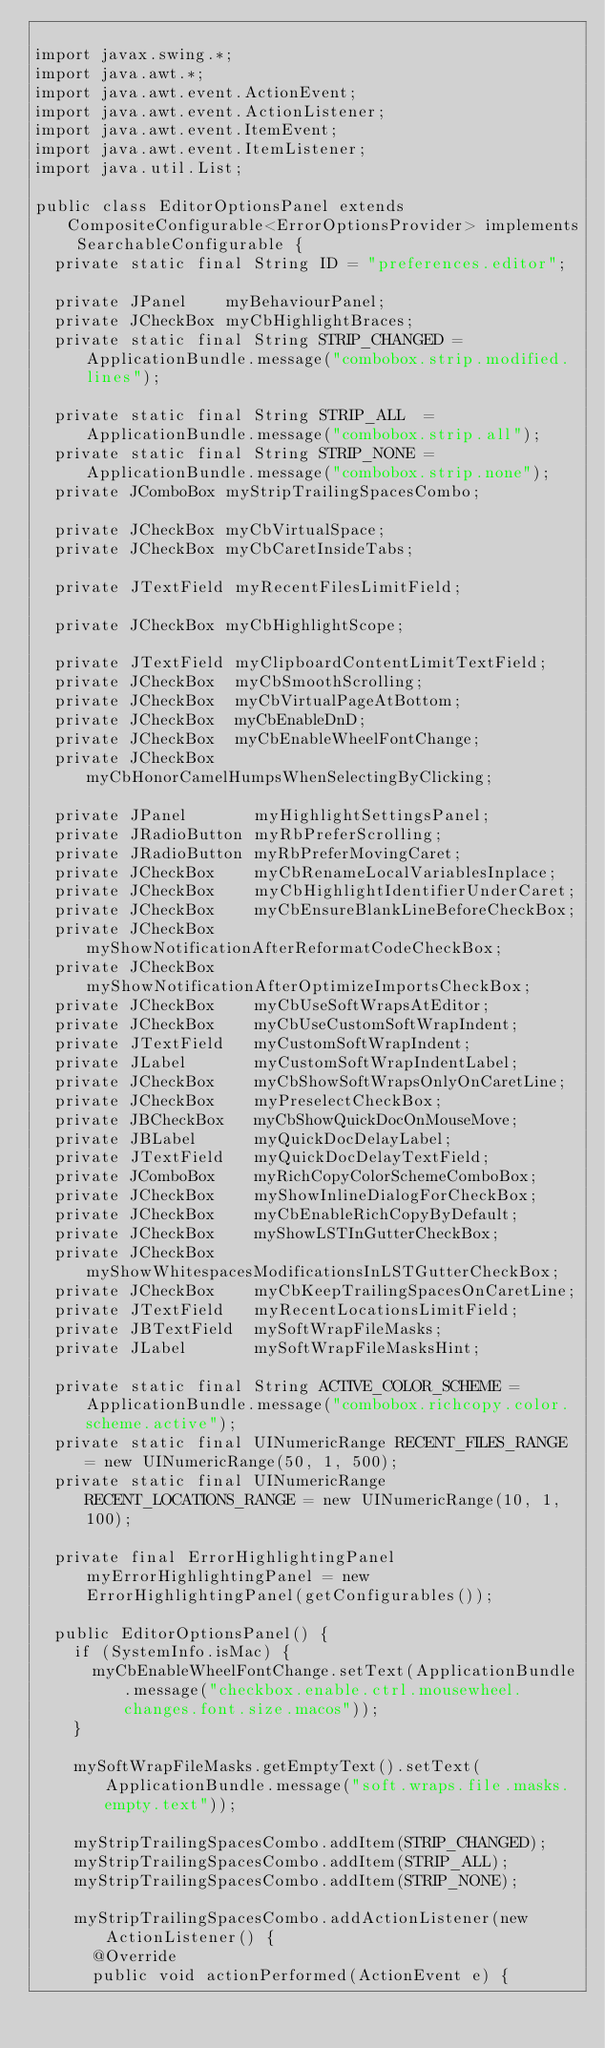Convert code to text. <code><loc_0><loc_0><loc_500><loc_500><_Java_>
import javax.swing.*;
import java.awt.*;
import java.awt.event.ActionEvent;
import java.awt.event.ActionListener;
import java.awt.event.ItemEvent;
import java.awt.event.ItemListener;
import java.util.List;

public class EditorOptionsPanel extends CompositeConfigurable<ErrorOptionsProvider> implements SearchableConfigurable {
  private static final String ID = "preferences.editor";

  private JPanel    myBehaviourPanel;
  private JCheckBox myCbHighlightBraces;
  private static final String STRIP_CHANGED = ApplicationBundle.message("combobox.strip.modified.lines");

  private static final String STRIP_ALL  = ApplicationBundle.message("combobox.strip.all");
  private static final String STRIP_NONE = ApplicationBundle.message("combobox.strip.none");
  private JComboBox myStripTrailingSpacesCombo;

  private JCheckBox myCbVirtualSpace;
  private JCheckBox myCbCaretInsideTabs;

  private JTextField myRecentFilesLimitField;

  private JCheckBox myCbHighlightScope;

  private JTextField myClipboardContentLimitTextField;
  private JCheckBox  myCbSmoothScrolling;
  private JCheckBox  myCbVirtualPageAtBottom;
  private JCheckBox  myCbEnableDnD;
  private JCheckBox  myCbEnableWheelFontChange;
  private JCheckBox  myCbHonorCamelHumpsWhenSelectingByClicking;

  private JPanel       myHighlightSettingsPanel;
  private JRadioButton myRbPreferScrolling;
  private JRadioButton myRbPreferMovingCaret;
  private JCheckBox    myCbRenameLocalVariablesInplace;
  private JCheckBox    myCbHighlightIdentifierUnderCaret;
  private JCheckBox    myCbEnsureBlankLineBeforeCheckBox;
  private JCheckBox    myShowNotificationAfterReformatCodeCheckBox;
  private JCheckBox    myShowNotificationAfterOptimizeImportsCheckBox;
  private JCheckBox    myCbUseSoftWrapsAtEditor;
  private JCheckBox    myCbUseCustomSoftWrapIndent;
  private JTextField   myCustomSoftWrapIndent;
  private JLabel       myCustomSoftWrapIndentLabel;
  private JCheckBox    myCbShowSoftWrapsOnlyOnCaretLine;
  private JCheckBox    myPreselectCheckBox;
  private JBCheckBox   myCbShowQuickDocOnMouseMove;
  private JBLabel      myQuickDocDelayLabel;
  private JTextField   myQuickDocDelayTextField;
  private JComboBox    myRichCopyColorSchemeComboBox;
  private JCheckBox    myShowInlineDialogForCheckBox;
  private JCheckBox    myCbEnableRichCopyByDefault;
  private JCheckBox    myShowLSTInGutterCheckBox;
  private JCheckBox    myShowWhitespacesModificationsInLSTGutterCheckBox;
  private JCheckBox    myCbKeepTrailingSpacesOnCaretLine;
  private JTextField   myRecentLocationsLimitField;
  private JBTextField  mySoftWrapFileMasks;
  private JLabel       mySoftWrapFileMasksHint;

  private static final String ACTIVE_COLOR_SCHEME = ApplicationBundle.message("combobox.richcopy.color.scheme.active");
  private static final UINumericRange RECENT_FILES_RANGE = new UINumericRange(50, 1, 500);
  private static final UINumericRange RECENT_LOCATIONS_RANGE = new UINumericRange(10, 1, 100);

  private final ErrorHighlightingPanel myErrorHighlightingPanel = new ErrorHighlightingPanel(getConfigurables());

  public EditorOptionsPanel() {
    if (SystemInfo.isMac) {
      myCbEnableWheelFontChange.setText(ApplicationBundle.message("checkbox.enable.ctrl.mousewheel.changes.font.size.macos"));
    }

    mySoftWrapFileMasks.getEmptyText().setText(ApplicationBundle.message("soft.wraps.file.masks.empty.text"));

    myStripTrailingSpacesCombo.addItem(STRIP_CHANGED);
    myStripTrailingSpacesCombo.addItem(STRIP_ALL);
    myStripTrailingSpacesCombo.addItem(STRIP_NONE);

    myStripTrailingSpacesCombo.addActionListener(new ActionListener() {
      @Override
      public void actionPerformed(ActionEvent e) {</code> 